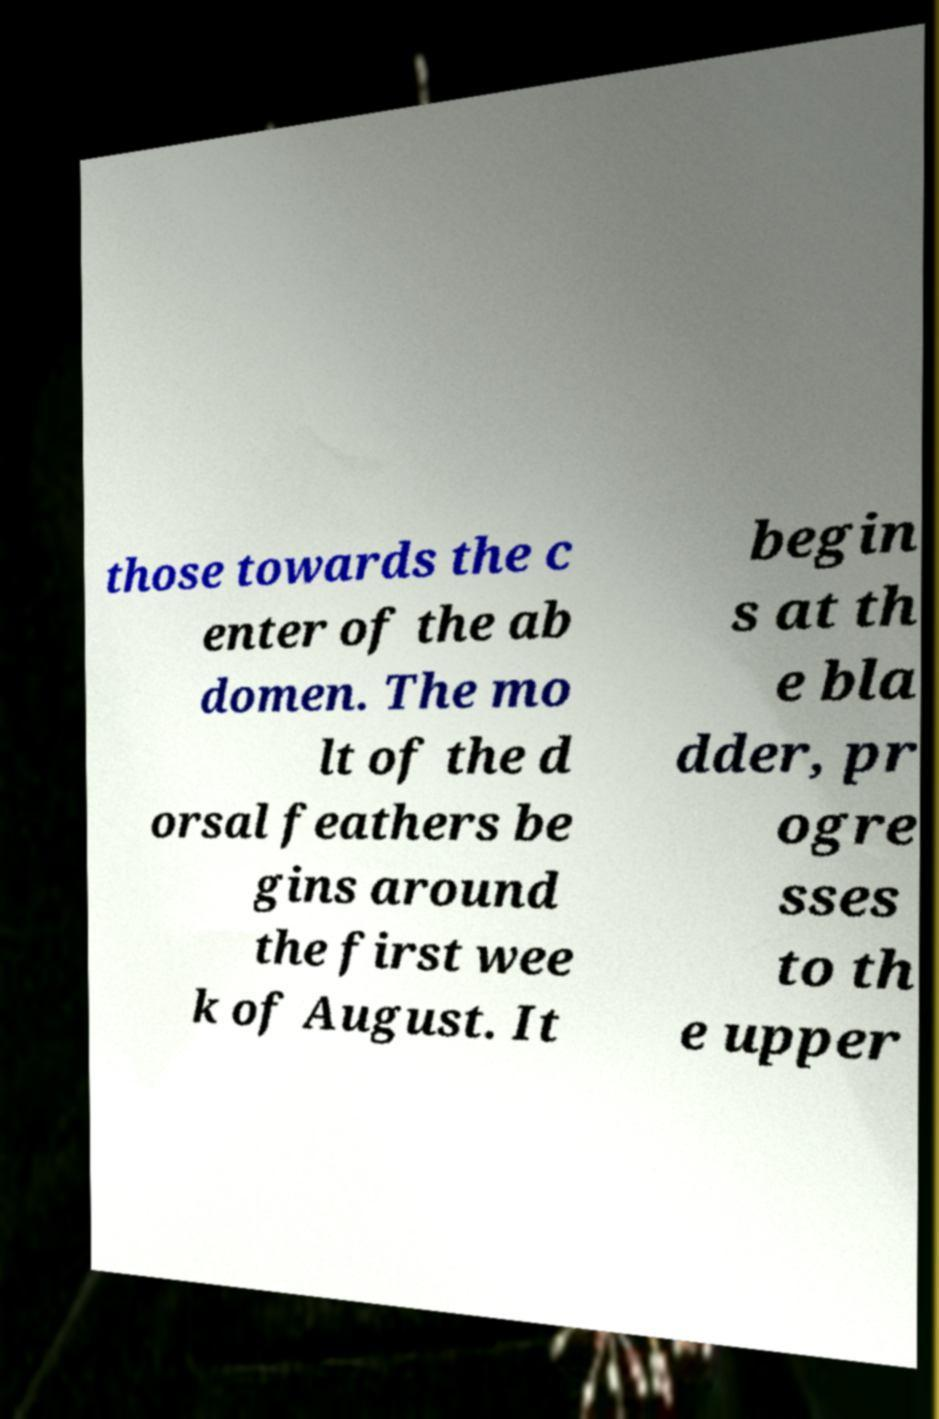There's text embedded in this image that I need extracted. Can you transcribe it verbatim? those towards the c enter of the ab domen. The mo lt of the d orsal feathers be gins around the first wee k of August. It begin s at th e bla dder, pr ogre sses to th e upper 